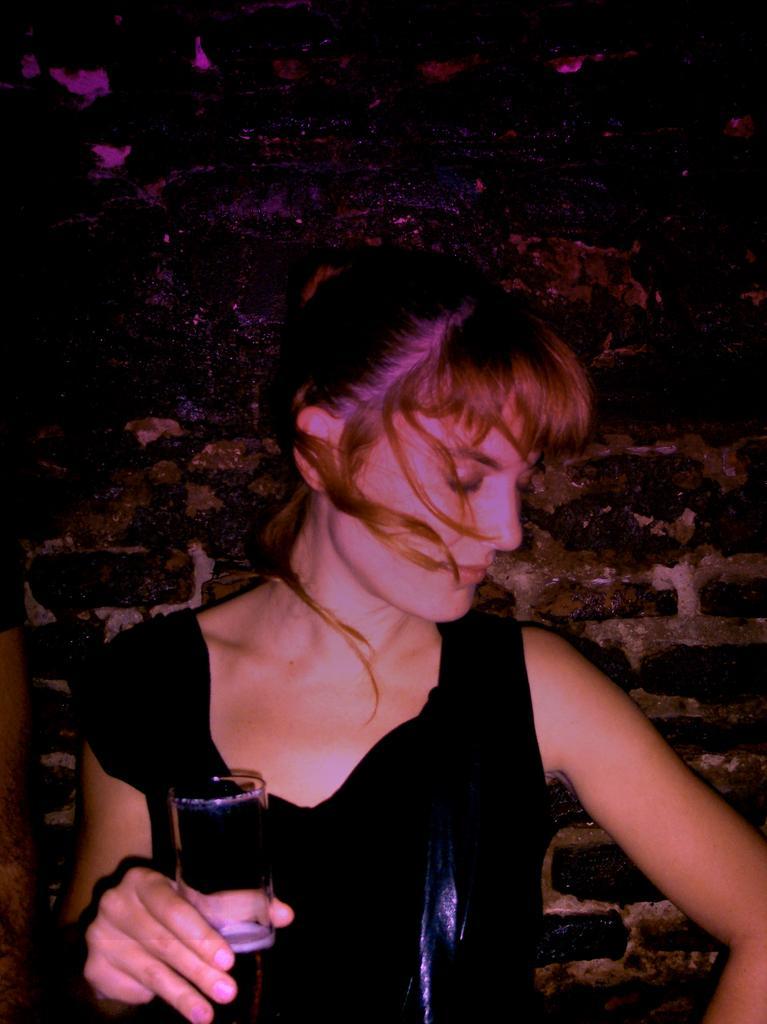Please provide a concise description of this image. In this image i can see a woman standing and wearing a black dress holding a glass at the back ground i can see a black wall. 